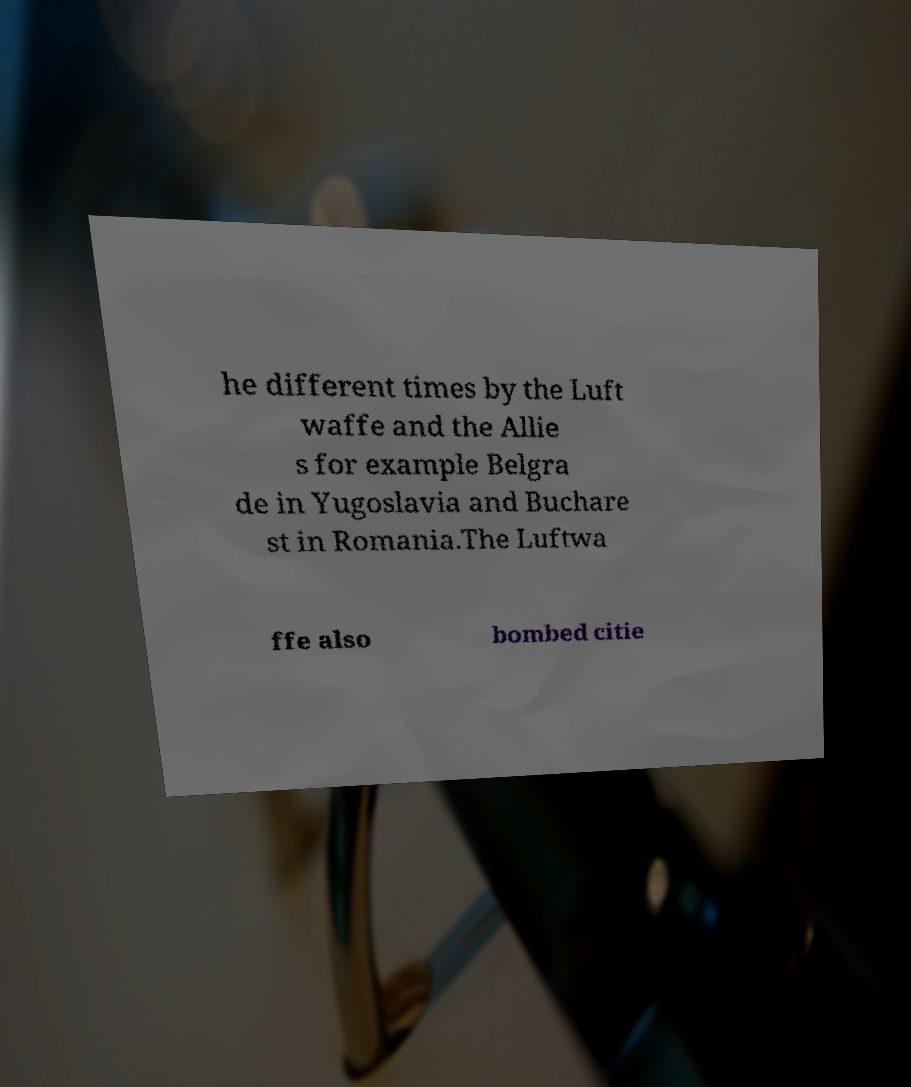Please identify and transcribe the text found in this image. he different times by the Luft waffe and the Allie s for example Belgra de in Yugoslavia and Buchare st in Romania.The Luftwa ffe also bombed citie 